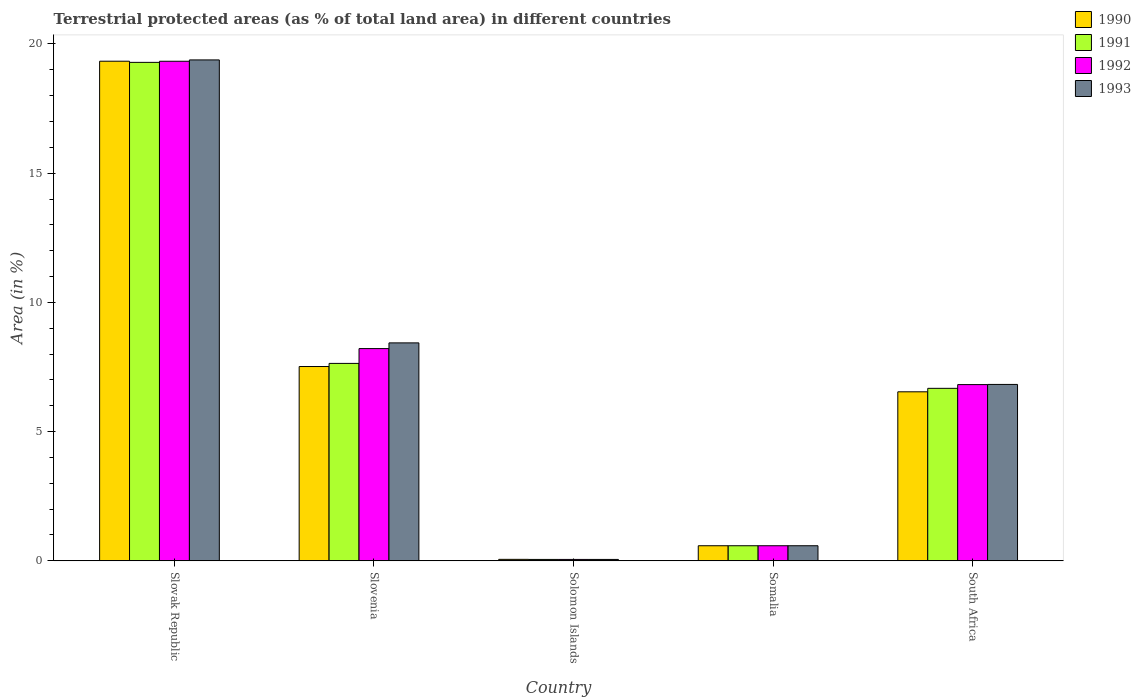How many groups of bars are there?
Give a very brief answer. 5. Are the number of bars per tick equal to the number of legend labels?
Your response must be concise. Yes. How many bars are there on the 1st tick from the left?
Your answer should be very brief. 4. How many bars are there on the 2nd tick from the right?
Your response must be concise. 4. What is the label of the 3rd group of bars from the left?
Offer a very short reply. Solomon Islands. What is the percentage of terrestrial protected land in 1991 in Somalia?
Your response must be concise. 0.58. Across all countries, what is the maximum percentage of terrestrial protected land in 1990?
Your answer should be very brief. 19.33. Across all countries, what is the minimum percentage of terrestrial protected land in 1992?
Provide a succinct answer. 0.05. In which country was the percentage of terrestrial protected land in 1992 maximum?
Ensure brevity in your answer.  Slovak Republic. In which country was the percentage of terrestrial protected land in 1992 minimum?
Provide a short and direct response. Solomon Islands. What is the total percentage of terrestrial protected land in 1992 in the graph?
Offer a terse response. 35. What is the difference between the percentage of terrestrial protected land in 1993 in Slovenia and that in South Africa?
Provide a short and direct response. 1.61. What is the difference between the percentage of terrestrial protected land in 1993 in South Africa and the percentage of terrestrial protected land in 1992 in Somalia?
Ensure brevity in your answer.  6.24. What is the average percentage of terrestrial protected land in 1990 per country?
Give a very brief answer. 6.81. What is the difference between the percentage of terrestrial protected land of/in 1992 and percentage of terrestrial protected land of/in 1990 in South Africa?
Offer a terse response. 0.28. In how many countries, is the percentage of terrestrial protected land in 1992 greater than 9 %?
Provide a succinct answer. 1. What is the ratio of the percentage of terrestrial protected land in 1991 in Slovenia to that in Solomon Islands?
Your answer should be very brief. 140.25. Is the difference between the percentage of terrestrial protected land in 1992 in Solomon Islands and South Africa greater than the difference between the percentage of terrestrial protected land in 1990 in Solomon Islands and South Africa?
Provide a succinct answer. No. What is the difference between the highest and the second highest percentage of terrestrial protected land in 1991?
Your answer should be compact. 12.61. What is the difference between the highest and the lowest percentage of terrestrial protected land in 1993?
Offer a very short reply. 19.33. In how many countries, is the percentage of terrestrial protected land in 1993 greater than the average percentage of terrestrial protected land in 1993 taken over all countries?
Keep it short and to the point. 2. Is the sum of the percentage of terrestrial protected land in 1992 in Slovak Republic and Somalia greater than the maximum percentage of terrestrial protected land in 1991 across all countries?
Provide a succinct answer. Yes. What does the 1st bar from the left in Slovenia represents?
Ensure brevity in your answer.  1990. What does the 4th bar from the right in Solomon Islands represents?
Offer a terse response. 1990. Is it the case that in every country, the sum of the percentage of terrestrial protected land in 1990 and percentage of terrestrial protected land in 1991 is greater than the percentage of terrestrial protected land in 1992?
Offer a very short reply. Yes. How many bars are there?
Offer a terse response. 20. Are all the bars in the graph horizontal?
Offer a terse response. No. How many countries are there in the graph?
Ensure brevity in your answer.  5. What is the difference between two consecutive major ticks on the Y-axis?
Give a very brief answer. 5. Are the values on the major ticks of Y-axis written in scientific E-notation?
Keep it short and to the point. No. Does the graph contain any zero values?
Your answer should be compact. No. Where does the legend appear in the graph?
Give a very brief answer. Top right. How many legend labels are there?
Offer a very short reply. 4. How are the legend labels stacked?
Your answer should be very brief. Vertical. What is the title of the graph?
Offer a terse response. Terrestrial protected areas (as % of total land area) in different countries. Does "1988" appear as one of the legend labels in the graph?
Provide a short and direct response. No. What is the label or title of the Y-axis?
Your answer should be very brief. Area (in %). What is the Area (in %) of 1990 in Slovak Republic?
Offer a very short reply. 19.33. What is the Area (in %) of 1991 in Slovak Republic?
Your answer should be very brief. 19.29. What is the Area (in %) in 1992 in Slovak Republic?
Offer a very short reply. 19.33. What is the Area (in %) of 1993 in Slovak Republic?
Offer a very short reply. 19.38. What is the Area (in %) of 1990 in Slovenia?
Provide a short and direct response. 7.52. What is the Area (in %) of 1991 in Slovenia?
Offer a very short reply. 7.64. What is the Area (in %) in 1992 in Slovenia?
Provide a succinct answer. 8.21. What is the Area (in %) in 1993 in Slovenia?
Provide a succinct answer. 8.43. What is the Area (in %) of 1990 in Solomon Islands?
Offer a terse response. 0.06. What is the Area (in %) of 1991 in Solomon Islands?
Provide a succinct answer. 0.05. What is the Area (in %) of 1992 in Solomon Islands?
Provide a succinct answer. 0.05. What is the Area (in %) in 1993 in Solomon Islands?
Your answer should be very brief. 0.05. What is the Area (in %) in 1990 in Somalia?
Offer a terse response. 0.58. What is the Area (in %) of 1991 in Somalia?
Provide a succinct answer. 0.58. What is the Area (in %) in 1992 in Somalia?
Offer a terse response. 0.58. What is the Area (in %) of 1993 in Somalia?
Make the answer very short. 0.58. What is the Area (in %) in 1990 in South Africa?
Your answer should be compact. 6.54. What is the Area (in %) of 1991 in South Africa?
Your answer should be very brief. 6.67. What is the Area (in %) of 1992 in South Africa?
Ensure brevity in your answer.  6.82. What is the Area (in %) of 1993 in South Africa?
Your response must be concise. 6.83. Across all countries, what is the maximum Area (in %) of 1990?
Your response must be concise. 19.33. Across all countries, what is the maximum Area (in %) of 1991?
Make the answer very short. 19.29. Across all countries, what is the maximum Area (in %) in 1992?
Provide a short and direct response. 19.33. Across all countries, what is the maximum Area (in %) of 1993?
Your answer should be compact. 19.38. Across all countries, what is the minimum Area (in %) in 1990?
Offer a terse response. 0.06. Across all countries, what is the minimum Area (in %) in 1991?
Your response must be concise. 0.05. Across all countries, what is the minimum Area (in %) in 1992?
Keep it short and to the point. 0.05. Across all countries, what is the minimum Area (in %) in 1993?
Offer a terse response. 0.05. What is the total Area (in %) in 1990 in the graph?
Your answer should be compact. 34.03. What is the total Area (in %) of 1991 in the graph?
Provide a short and direct response. 34.24. What is the total Area (in %) of 1993 in the graph?
Offer a terse response. 35.28. What is the difference between the Area (in %) of 1990 in Slovak Republic and that in Slovenia?
Ensure brevity in your answer.  11.81. What is the difference between the Area (in %) in 1991 in Slovak Republic and that in Slovenia?
Ensure brevity in your answer.  11.65. What is the difference between the Area (in %) of 1992 in Slovak Republic and that in Slovenia?
Provide a succinct answer. 11.12. What is the difference between the Area (in %) in 1993 in Slovak Republic and that in Slovenia?
Ensure brevity in your answer.  10.95. What is the difference between the Area (in %) of 1990 in Slovak Republic and that in Solomon Islands?
Make the answer very short. 19.27. What is the difference between the Area (in %) in 1991 in Slovak Republic and that in Solomon Islands?
Ensure brevity in your answer.  19.23. What is the difference between the Area (in %) in 1992 in Slovak Republic and that in Solomon Islands?
Offer a very short reply. 19.28. What is the difference between the Area (in %) of 1993 in Slovak Republic and that in Solomon Islands?
Ensure brevity in your answer.  19.33. What is the difference between the Area (in %) of 1990 in Slovak Republic and that in Somalia?
Your response must be concise. 18.75. What is the difference between the Area (in %) of 1991 in Slovak Republic and that in Somalia?
Keep it short and to the point. 18.7. What is the difference between the Area (in %) of 1992 in Slovak Republic and that in Somalia?
Your response must be concise. 18.75. What is the difference between the Area (in %) in 1993 in Slovak Republic and that in Somalia?
Keep it short and to the point. 18.8. What is the difference between the Area (in %) of 1990 in Slovak Republic and that in South Africa?
Provide a short and direct response. 12.79. What is the difference between the Area (in %) in 1991 in Slovak Republic and that in South Africa?
Keep it short and to the point. 12.61. What is the difference between the Area (in %) of 1992 in Slovak Republic and that in South Africa?
Your answer should be compact. 12.51. What is the difference between the Area (in %) of 1993 in Slovak Republic and that in South Africa?
Your answer should be very brief. 12.56. What is the difference between the Area (in %) of 1990 in Slovenia and that in Solomon Islands?
Ensure brevity in your answer.  7.46. What is the difference between the Area (in %) of 1991 in Slovenia and that in Solomon Islands?
Provide a short and direct response. 7.58. What is the difference between the Area (in %) in 1992 in Slovenia and that in Solomon Islands?
Your response must be concise. 8.16. What is the difference between the Area (in %) of 1993 in Slovenia and that in Solomon Islands?
Keep it short and to the point. 8.38. What is the difference between the Area (in %) in 1990 in Slovenia and that in Somalia?
Give a very brief answer. 6.93. What is the difference between the Area (in %) of 1991 in Slovenia and that in Somalia?
Your response must be concise. 7.06. What is the difference between the Area (in %) in 1992 in Slovenia and that in Somalia?
Provide a short and direct response. 7.63. What is the difference between the Area (in %) of 1993 in Slovenia and that in Somalia?
Your answer should be compact. 7.85. What is the difference between the Area (in %) of 1990 in Slovenia and that in South Africa?
Your answer should be very brief. 0.98. What is the difference between the Area (in %) of 1991 in Slovenia and that in South Africa?
Your answer should be very brief. 0.97. What is the difference between the Area (in %) in 1992 in Slovenia and that in South Africa?
Your answer should be compact. 1.39. What is the difference between the Area (in %) in 1993 in Slovenia and that in South Africa?
Your answer should be compact. 1.61. What is the difference between the Area (in %) of 1990 in Solomon Islands and that in Somalia?
Provide a succinct answer. -0.53. What is the difference between the Area (in %) in 1991 in Solomon Islands and that in Somalia?
Your answer should be compact. -0.53. What is the difference between the Area (in %) in 1992 in Solomon Islands and that in Somalia?
Offer a terse response. -0.53. What is the difference between the Area (in %) in 1993 in Solomon Islands and that in Somalia?
Your answer should be compact. -0.53. What is the difference between the Area (in %) in 1990 in Solomon Islands and that in South Africa?
Offer a very short reply. -6.48. What is the difference between the Area (in %) of 1991 in Solomon Islands and that in South Africa?
Ensure brevity in your answer.  -6.62. What is the difference between the Area (in %) of 1992 in Solomon Islands and that in South Africa?
Give a very brief answer. -6.76. What is the difference between the Area (in %) of 1993 in Solomon Islands and that in South Africa?
Ensure brevity in your answer.  -6.77. What is the difference between the Area (in %) in 1990 in Somalia and that in South Africa?
Offer a very short reply. -5.96. What is the difference between the Area (in %) of 1991 in Somalia and that in South Africa?
Make the answer very short. -6.09. What is the difference between the Area (in %) of 1992 in Somalia and that in South Africa?
Provide a succinct answer. -6.23. What is the difference between the Area (in %) in 1993 in Somalia and that in South Africa?
Provide a short and direct response. -6.24. What is the difference between the Area (in %) of 1990 in Slovak Republic and the Area (in %) of 1991 in Slovenia?
Your answer should be very brief. 11.69. What is the difference between the Area (in %) of 1990 in Slovak Republic and the Area (in %) of 1992 in Slovenia?
Ensure brevity in your answer.  11.12. What is the difference between the Area (in %) in 1990 in Slovak Republic and the Area (in %) in 1993 in Slovenia?
Your response must be concise. 10.9. What is the difference between the Area (in %) of 1991 in Slovak Republic and the Area (in %) of 1992 in Slovenia?
Make the answer very short. 11.08. What is the difference between the Area (in %) in 1991 in Slovak Republic and the Area (in %) in 1993 in Slovenia?
Your response must be concise. 10.85. What is the difference between the Area (in %) of 1992 in Slovak Republic and the Area (in %) of 1993 in Slovenia?
Your answer should be compact. 10.9. What is the difference between the Area (in %) in 1990 in Slovak Republic and the Area (in %) in 1991 in Solomon Islands?
Your response must be concise. 19.28. What is the difference between the Area (in %) in 1990 in Slovak Republic and the Area (in %) in 1992 in Solomon Islands?
Your answer should be very brief. 19.28. What is the difference between the Area (in %) in 1990 in Slovak Republic and the Area (in %) in 1993 in Solomon Islands?
Ensure brevity in your answer.  19.28. What is the difference between the Area (in %) in 1991 in Slovak Republic and the Area (in %) in 1992 in Solomon Islands?
Offer a terse response. 19.23. What is the difference between the Area (in %) in 1991 in Slovak Republic and the Area (in %) in 1993 in Solomon Islands?
Provide a short and direct response. 19.23. What is the difference between the Area (in %) of 1992 in Slovak Republic and the Area (in %) of 1993 in Solomon Islands?
Give a very brief answer. 19.28. What is the difference between the Area (in %) of 1990 in Slovak Republic and the Area (in %) of 1991 in Somalia?
Your answer should be very brief. 18.75. What is the difference between the Area (in %) in 1990 in Slovak Republic and the Area (in %) in 1992 in Somalia?
Keep it short and to the point. 18.75. What is the difference between the Area (in %) in 1990 in Slovak Republic and the Area (in %) in 1993 in Somalia?
Make the answer very short. 18.75. What is the difference between the Area (in %) in 1991 in Slovak Republic and the Area (in %) in 1992 in Somalia?
Ensure brevity in your answer.  18.7. What is the difference between the Area (in %) in 1991 in Slovak Republic and the Area (in %) in 1993 in Somalia?
Ensure brevity in your answer.  18.7. What is the difference between the Area (in %) of 1992 in Slovak Republic and the Area (in %) of 1993 in Somalia?
Make the answer very short. 18.75. What is the difference between the Area (in %) in 1990 in Slovak Republic and the Area (in %) in 1991 in South Africa?
Offer a terse response. 12.66. What is the difference between the Area (in %) of 1990 in Slovak Republic and the Area (in %) of 1992 in South Africa?
Your answer should be very brief. 12.51. What is the difference between the Area (in %) of 1990 in Slovak Republic and the Area (in %) of 1993 in South Africa?
Ensure brevity in your answer.  12.51. What is the difference between the Area (in %) of 1991 in Slovak Republic and the Area (in %) of 1992 in South Africa?
Provide a succinct answer. 12.47. What is the difference between the Area (in %) of 1991 in Slovak Republic and the Area (in %) of 1993 in South Africa?
Provide a succinct answer. 12.46. What is the difference between the Area (in %) in 1992 in Slovak Republic and the Area (in %) in 1993 in South Africa?
Your answer should be compact. 12.5. What is the difference between the Area (in %) of 1990 in Slovenia and the Area (in %) of 1991 in Solomon Islands?
Your answer should be very brief. 7.46. What is the difference between the Area (in %) of 1990 in Slovenia and the Area (in %) of 1992 in Solomon Islands?
Offer a terse response. 7.46. What is the difference between the Area (in %) in 1990 in Slovenia and the Area (in %) in 1993 in Solomon Islands?
Keep it short and to the point. 7.46. What is the difference between the Area (in %) of 1991 in Slovenia and the Area (in %) of 1992 in Solomon Islands?
Provide a succinct answer. 7.58. What is the difference between the Area (in %) of 1991 in Slovenia and the Area (in %) of 1993 in Solomon Islands?
Offer a terse response. 7.58. What is the difference between the Area (in %) of 1992 in Slovenia and the Area (in %) of 1993 in Solomon Islands?
Give a very brief answer. 8.16. What is the difference between the Area (in %) in 1990 in Slovenia and the Area (in %) in 1991 in Somalia?
Offer a very short reply. 6.93. What is the difference between the Area (in %) of 1990 in Slovenia and the Area (in %) of 1992 in Somalia?
Keep it short and to the point. 6.93. What is the difference between the Area (in %) in 1990 in Slovenia and the Area (in %) in 1993 in Somalia?
Provide a short and direct response. 6.93. What is the difference between the Area (in %) of 1991 in Slovenia and the Area (in %) of 1992 in Somalia?
Give a very brief answer. 7.06. What is the difference between the Area (in %) of 1991 in Slovenia and the Area (in %) of 1993 in Somalia?
Offer a terse response. 7.06. What is the difference between the Area (in %) of 1992 in Slovenia and the Area (in %) of 1993 in Somalia?
Offer a terse response. 7.63. What is the difference between the Area (in %) in 1990 in Slovenia and the Area (in %) in 1991 in South Africa?
Provide a short and direct response. 0.84. What is the difference between the Area (in %) in 1990 in Slovenia and the Area (in %) in 1993 in South Africa?
Provide a succinct answer. 0.69. What is the difference between the Area (in %) of 1991 in Slovenia and the Area (in %) of 1992 in South Africa?
Provide a succinct answer. 0.82. What is the difference between the Area (in %) of 1991 in Slovenia and the Area (in %) of 1993 in South Africa?
Offer a terse response. 0.81. What is the difference between the Area (in %) of 1992 in Slovenia and the Area (in %) of 1993 in South Africa?
Offer a terse response. 1.39. What is the difference between the Area (in %) in 1990 in Solomon Islands and the Area (in %) in 1991 in Somalia?
Your response must be concise. -0.53. What is the difference between the Area (in %) in 1990 in Solomon Islands and the Area (in %) in 1992 in Somalia?
Your answer should be very brief. -0.53. What is the difference between the Area (in %) in 1990 in Solomon Islands and the Area (in %) in 1993 in Somalia?
Your response must be concise. -0.53. What is the difference between the Area (in %) in 1991 in Solomon Islands and the Area (in %) in 1992 in Somalia?
Ensure brevity in your answer.  -0.53. What is the difference between the Area (in %) in 1991 in Solomon Islands and the Area (in %) in 1993 in Somalia?
Make the answer very short. -0.53. What is the difference between the Area (in %) of 1992 in Solomon Islands and the Area (in %) of 1993 in Somalia?
Ensure brevity in your answer.  -0.53. What is the difference between the Area (in %) of 1990 in Solomon Islands and the Area (in %) of 1991 in South Africa?
Your answer should be compact. -6.62. What is the difference between the Area (in %) in 1990 in Solomon Islands and the Area (in %) in 1992 in South Africa?
Ensure brevity in your answer.  -6.76. What is the difference between the Area (in %) of 1990 in Solomon Islands and the Area (in %) of 1993 in South Africa?
Offer a terse response. -6.77. What is the difference between the Area (in %) in 1991 in Solomon Islands and the Area (in %) in 1992 in South Africa?
Provide a succinct answer. -6.76. What is the difference between the Area (in %) of 1991 in Solomon Islands and the Area (in %) of 1993 in South Africa?
Make the answer very short. -6.77. What is the difference between the Area (in %) in 1992 in Solomon Islands and the Area (in %) in 1993 in South Africa?
Your answer should be compact. -6.77. What is the difference between the Area (in %) in 1990 in Somalia and the Area (in %) in 1991 in South Africa?
Your response must be concise. -6.09. What is the difference between the Area (in %) in 1990 in Somalia and the Area (in %) in 1992 in South Africa?
Provide a short and direct response. -6.23. What is the difference between the Area (in %) of 1990 in Somalia and the Area (in %) of 1993 in South Africa?
Ensure brevity in your answer.  -6.24. What is the difference between the Area (in %) in 1991 in Somalia and the Area (in %) in 1992 in South Africa?
Provide a short and direct response. -6.23. What is the difference between the Area (in %) in 1991 in Somalia and the Area (in %) in 1993 in South Africa?
Your answer should be very brief. -6.24. What is the difference between the Area (in %) of 1992 in Somalia and the Area (in %) of 1993 in South Africa?
Offer a very short reply. -6.24. What is the average Area (in %) of 1990 per country?
Your answer should be very brief. 6.81. What is the average Area (in %) of 1991 per country?
Provide a succinct answer. 6.85. What is the average Area (in %) of 1993 per country?
Offer a terse response. 7.06. What is the difference between the Area (in %) in 1990 and Area (in %) in 1991 in Slovak Republic?
Keep it short and to the point. 0.04. What is the difference between the Area (in %) in 1990 and Area (in %) in 1992 in Slovak Republic?
Your answer should be compact. 0. What is the difference between the Area (in %) of 1990 and Area (in %) of 1993 in Slovak Republic?
Offer a terse response. -0.05. What is the difference between the Area (in %) in 1991 and Area (in %) in 1992 in Slovak Republic?
Provide a succinct answer. -0.04. What is the difference between the Area (in %) in 1991 and Area (in %) in 1993 in Slovak Republic?
Offer a very short reply. -0.09. What is the difference between the Area (in %) in 1992 and Area (in %) in 1993 in Slovak Republic?
Ensure brevity in your answer.  -0.05. What is the difference between the Area (in %) in 1990 and Area (in %) in 1991 in Slovenia?
Your answer should be very brief. -0.12. What is the difference between the Area (in %) in 1990 and Area (in %) in 1992 in Slovenia?
Offer a terse response. -0.69. What is the difference between the Area (in %) in 1990 and Area (in %) in 1993 in Slovenia?
Make the answer very short. -0.91. What is the difference between the Area (in %) in 1991 and Area (in %) in 1992 in Slovenia?
Offer a very short reply. -0.57. What is the difference between the Area (in %) of 1991 and Area (in %) of 1993 in Slovenia?
Your answer should be compact. -0.79. What is the difference between the Area (in %) of 1992 and Area (in %) of 1993 in Slovenia?
Provide a short and direct response. -0.22. What is the difference between the Area (in %) in 1990 and Area (in %) in 1991 in Solomon Islands?
Provide a succinct answer. 0. What is the difference between the Area (in %) in 1990 and Area (in %) in 1992 in Solomon Islands?
Give a very brief answer. 0. What is the difference between the Area (in %) of 1990 and Area (in %) of 1993 in Solomon Islands?
Ensure brevity in your answer.  0. What is the difference between the Area (in %) of 1991 and Area (in %) of 1992 in Solomon Islands?
Your answer should be very brief. 0. What is the difference between the Area (in %) of 1991 and Area (in %) of 1993 in Solomon Islands?
Your answer should be very brief. 0. What is the difference between the Area (in %) of 1992 and Area (in %) of 1993 in Solomon Islands?
Your answer should be compact. 0. What is the difference between the Area (in %) of 1992 and Area (in %) of 1993 in Somalia?
Your answer should be very brief. 0. What is the difference between the Area (in %) in 1990 and Area (in %) in 1991 in South Africa?
Offer a terse response. -0.13. What is the difference between the Area (in %) of 1990 and Area (in %) of 1992 in South Africa?
Ensure brevity in your answer.  -0.28. What is the difference between the Area (in %) in 1990 and Area (in %) in 1993 in South Africa?
Your answer should be compact. -0.29. What is the difference between the Area (in %) in 1991 and Area (in %) in 1992 in South Africa?
Offer a very short reply. -0.14. What is the difference between the Area (in %) of 1991 and Area (in %) of 1993 in South Africa?
Your answer should be very brief. -0.15. What is the difference between the Area (in %) of 1992 and Area (in %) of 1993 in South Africa?
Keep it short and to the point. -0.01. What is the ratio of the Area (in %) in 1990 in Slovak Republic to that in Slovenia?
Offer a very short reply. 2.57. What is the ratio of the Area (in %) of 1991 in Slovak Republic to that in Slovenia?
Offer a very short reply. 2.52. What is the ratio of the Area (in %) of 1992 in Slovak Republic to that in Slovenia?
Ensure brevity in your answer.  2.35. What is the ratio of the Area (in %) in 1993 in Slovak Republic to that in Slovenia?
Give a very brief answer. 2.3. What is the ratio of the Area (in %) in 1990 in Slovak Republic to that in Solomon Islands?
Provide a succinct answer. 336.26. What is the ratio of the Area (in %) of 1991 in Slovak Republic to that in Solomon Islands?
Provide a succinct answer. 354.1. What is the ratio of the Area (in %) in 1992 in Slovak Republic to that in Solomon Islands?
Offer a very short reply. 354.88. What is the ratio of the Area (in %) in 1993 in Slovak Republic to that in Solomon Islands?
Provide a succinct answer. 355.84. What is the ratio of the Area (in %) of 1990 in Slovak Republic to that in Somalia?
Give a very brief answer. 33.1. What is the ratio of the Area (in %) of 1991 in Slovak Republic to that in Somalia?
Your response must be concise. 33.03. What is the ratio of the Area (in %) in 1992 in Slovak Republic to that in Somalia?
Give a very brief answer. 33.1. What is the ratio of the Area (in %) of 1993 in Slovak Republic to that in Somalia?
Your answer should be compact. 33.19. What is the ratio of the Area (in %) in 1990 in Slovak Republic to that in South Africa?
Your answer should be compact. 2.96. What is the ratio of the Area (in %) in 1991 in Slovak Republic to that in South Africa?
Ensure brevity in your answer.  2.89. What is the ratio of the Area (in %) of 1992 in Slovak Republic to that in South Africa?
Ensure brevity in your answer.  2.83. What is the ratio of the Area (in %) in 1993 in Slovak Republic to that in South Africa?
Your answer should be very brief. 2.84. What is the ratio of the Area (in %) in 1990 in Slovenia to that in Solomon Islands?
Provide a short and direct response. 130.78. What is the ratio of the Area (in %) in 1991 in Slovenia to that in Solomon Islands?
Provide a short and direct response. 140.25. What is the ratio of the Area (in %) of 1992 in Slovenia to that in Solomon Islands?
Keep it short and to the point. 150.77. What is the ratio of the Area (in %) in 1993 in Slovenia to that in Solomon Islands?
Offer a terse response. 154.83. What is the ratio of the Area (in %) in 1990 in Slovenia to that in Somalia?
Offer a terse response. 12.87. What is the ratio of the Area (in %) in 1991 in Slovenia to that in Somalia?
Provide a succinct answer. 13.08. What is the ratio of the Area (in %) in 1992 in Slovenia to that in Somalia?
Your answer should be compact. 14.06. What is the ratio of the Area (in %) in 1993 in Slovenia to that in Somalia?
Make the answer very short. 14.44. What is the ratio of the Area (in %) in 1990 in Slovenia to that in South Africa?
Your answer should be compact. 1.15. What is the ratio of the Area (in %) of 1991 in Slovenia to that in South Africa?
Offer a terse response. 1.14. What is the ratio of the Area (in %) in 1992 in Slovenia to that in South Africa?
Your response must be concise. 1.2. What is the ratio of the Area (in %) in 1993 in Slovenia to that in South Africa?
Your answer should be compact. 1.24. What is the ratio of the Area (in %) of 1990 in Solomon Islands to that in Somalia?
Your answer should be compact. 0.1. What is the ratio of the Area (in %) of 1991 in Solomon Islands to that in Somalia?
Your answer should be very brief. 0.09. What is the ratio of the Area (in %) in 1992 in Solomon Islands to that in Somalia?
Give a very brief answer. 0.09. What is the ratio of the Area (in %) in 1993 in Solomon Islands to that in Somalia?
Provide a succinct answer. 0.09. What is the ratio of the Area (in %) in 1990 in Solomon Islands to that in South Africa?
Give a very brief answer. 0.01. What is the ratio of the Area (in %) in 1991 in Solomon Islands to that in South Africa?
Ensure brevity in your answer.  0.01. What is the ratio of the Area (in %) in 1992 in Solomon Islands to that in South Africa?
Your response must be concise. 0.01. What is the ratio of the Area (in %) in 1993 in Solomon Islands to that in South Africa?
Offer a very short reply. 0.01. What is the ratio of the Area (in %) of 1990 in Somalia to that in South Africa?
Offer a very short reply. 0.09. What is the ratio of the Area (in %) in 1991 in Somalia to that in South Africa?
Offer a very short reply. 0.09. What is the ratio of the Area (in %) of 1992 in Somalia to that in South Africa?
Offer a very short reply. 0.09. What is the ratio of the Area (in %) in 1993 in Somalia to that in South Africa?
Your response must be concise. 0.09. What is the difference between the highest and the second highest Area (in %) of 1990?
Make the answer very short. 11.81. What is the difference between the highest and the second highest Area (in %) in 1991?
Provide a short and direct response. 11.65. What is the difference between the highest and the second highest Area (in %) of 1992?
Your answer should be very brief. 11.12. What is the difference between the highest and the second highest Area (in %) in 1993?
Offer a very short reply. 10.95. What is the difference between the highest and the lowest Area (in %) in 1990?
Your answer should be compact. 19.27. What is the difference between the highest and the lowest Area (in %) in 1991?
Ensure brevity in your answer.  19.23. What is the difference between the highest and the lowest Area (in %) in 1992?
Your answer should be compact. 19.28. What is the difference between the highest and the lowest Area (in %) in 1993?
Keep it short and to the point. 19.33. 